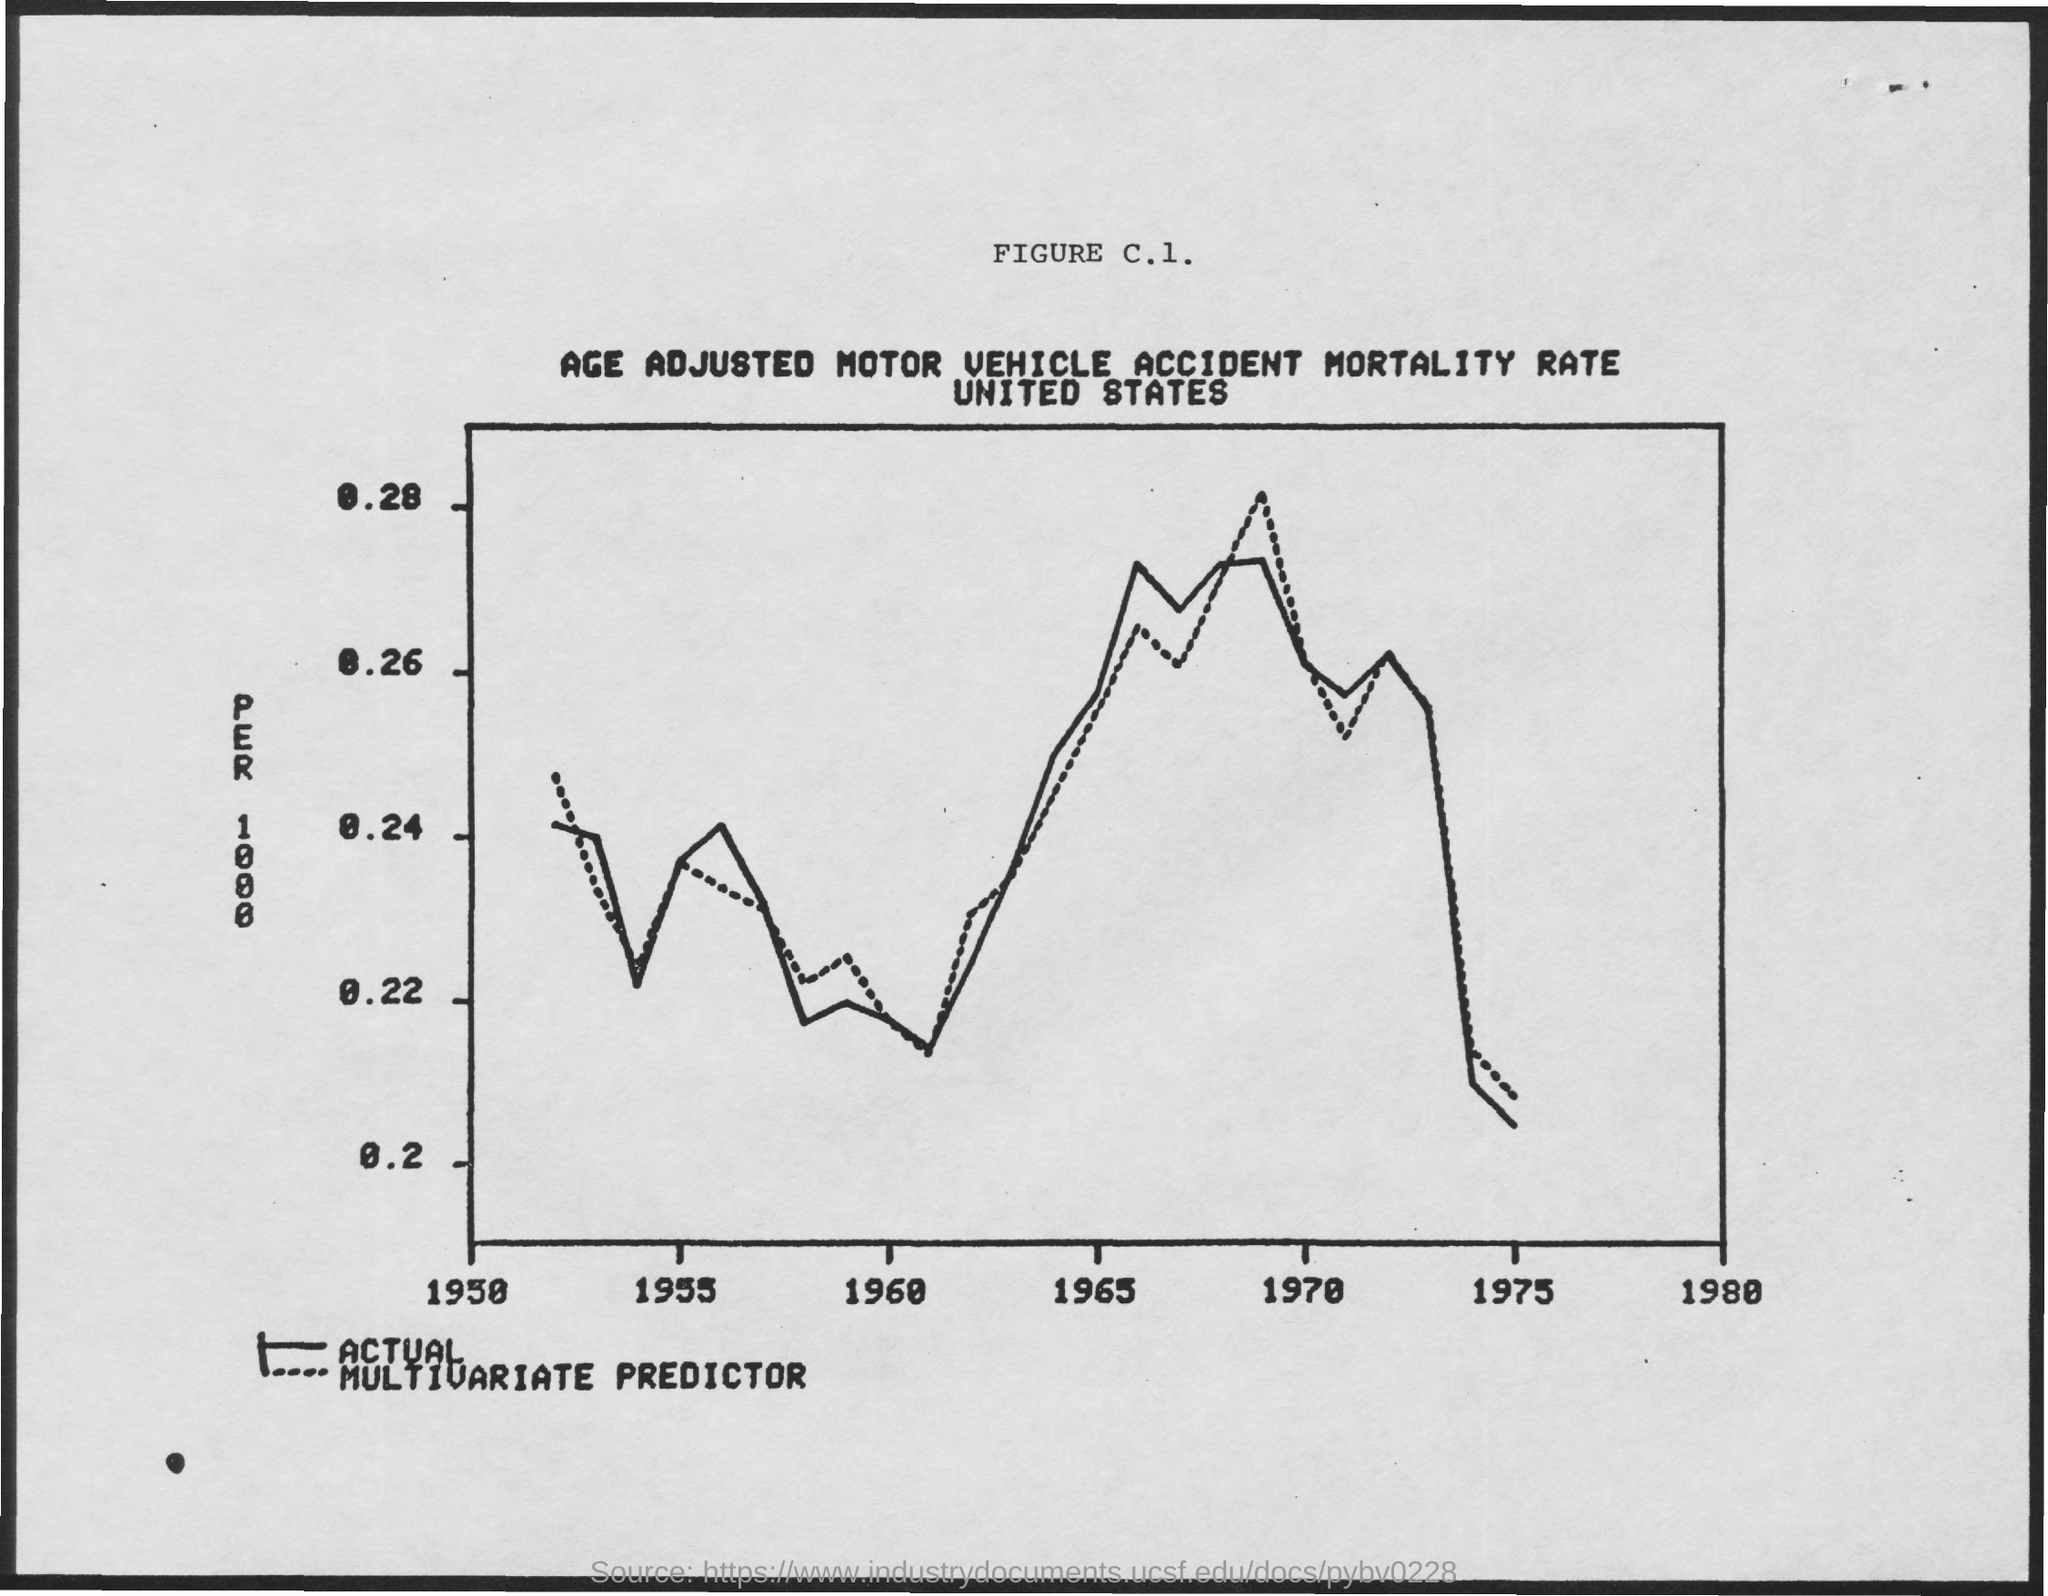What is the title of the FIGURE C.1.?
Give a very brief answer. AGE ADJUSTED MOTOR VEHICLE ACCIDENT MORTALITY RATE UNITED STATES. What is the maximum limit given on the y-axis of the figure c.1?
Ensure brevity in your answer.  0.28. 